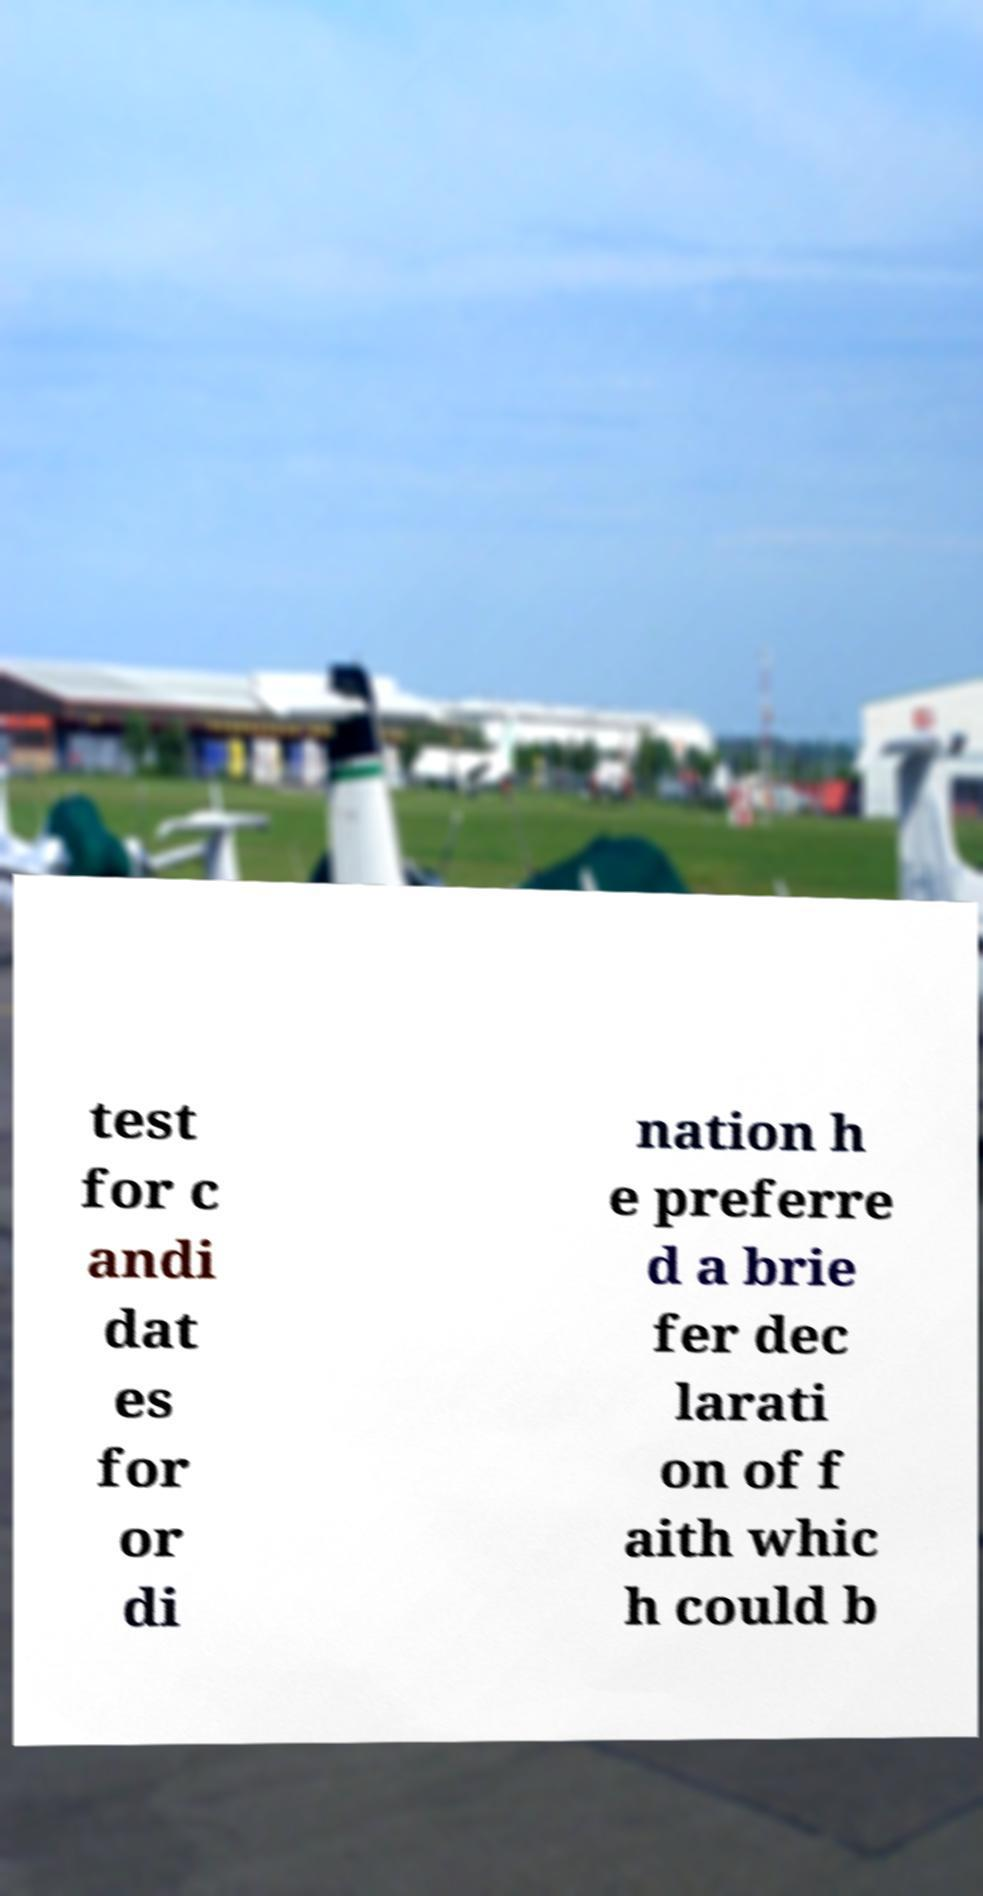I need the written content from this picture converted into text. Can you do that? test for c andi dat es for or di nation h e preferre d a brie fer dec larati on of f aith whic h could b 